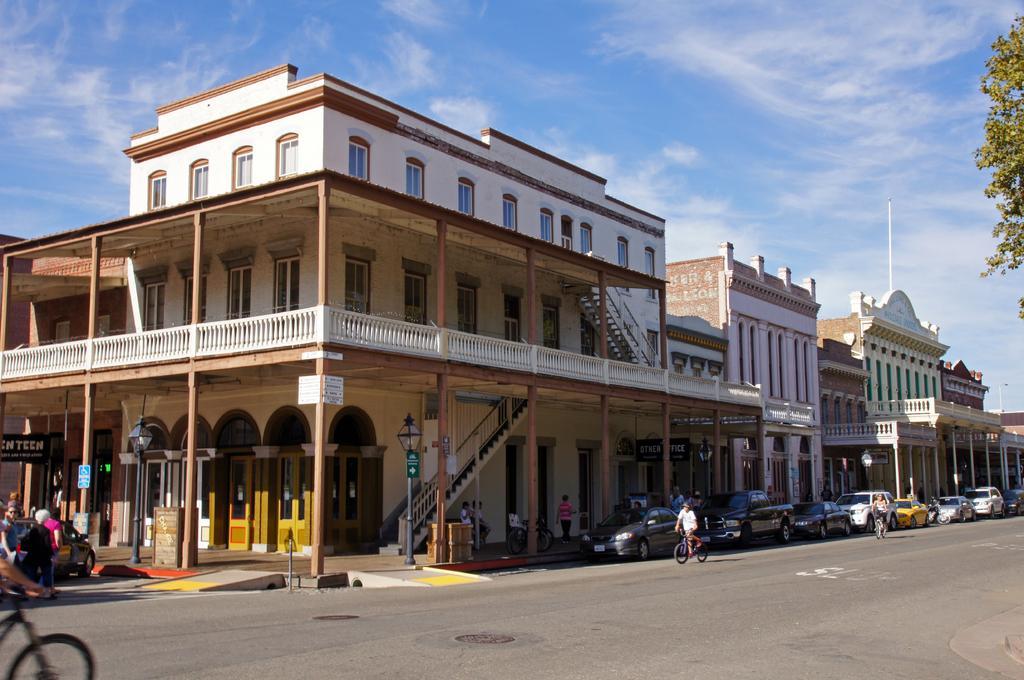Please provide a concise description of this image. There are buildings in the middle of an image, on the right side few cars are parked on the road and there are trees. At the top it is the blue color sky. 